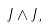Convert formula to latex. <formula><loc_0><loc_0><loc_500><loc_500>J \wedge J ,</formula> 